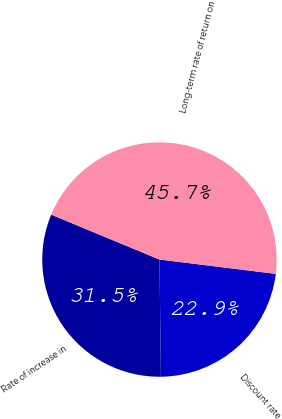<chart> <loc_0><loc_0><loc_500><loc_500><pie_chart><fcel>Discount rate<fcel>Rate of increase in<fcel>Long-term rate of return on<nl><fcel>22.85%<fcel>31.45%<fcel>45.7%<nl></chart> 